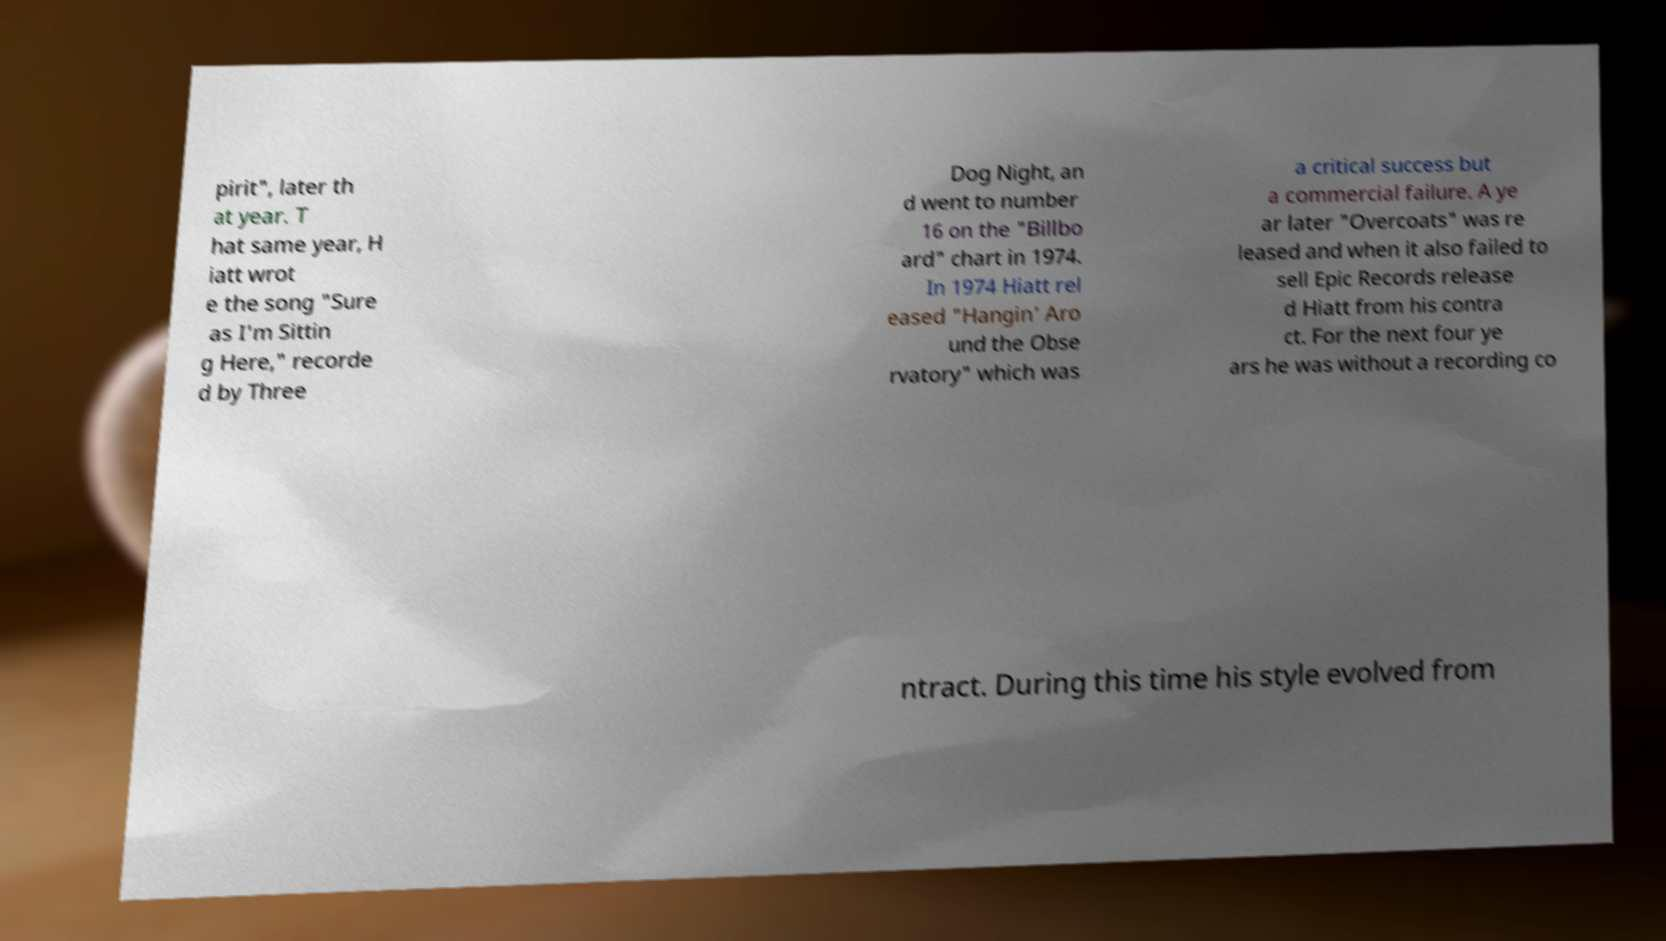There's text embedded in this image that I need extracted. Can you transcribe it verbatim? pirit", later th at year. T hat same year, H iatt wrot e the song "Sure as I'm Sittin g Here," recorde d by Three Dog Night, an d went to number 16 on the "Billbo ard" chart in 1974. In 1974 Hiatt rel eased "Hangin' Aro und the Obse rvatory" which was a critical success but a commercial failure. A ye ar later "Overcoats" was re leased and when it also failed to sell Epic Records release d Hiatt from his contra ct. For the next four ye ars he was without a recording co ntract. During this time his style evolved from 